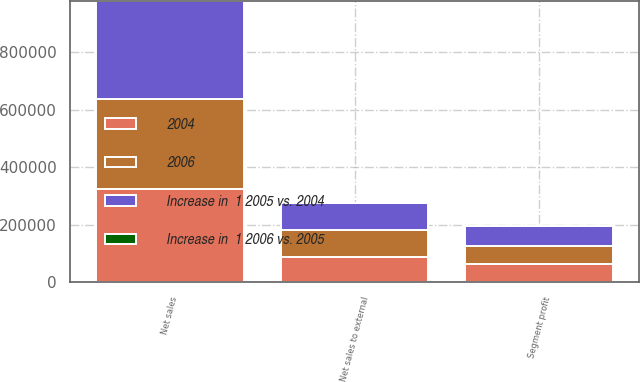<chart> <loc_0><loc_0><loc_500><loc_500><stacked_bar_chart><ecel><fcel>Net sales<fcel>Net sales to external<fcel>Segment profit<nl><fcel>Increase in  1 2005 vs. 2004<fcel>340849<fcel>96311<fcel>70083<nl><fcel>2004<fcel>324901<fcel>88138<fcel>65471<nl><fcel>2006<fcel>312992<fcel>92321<fcel>59576<nl><fcel>Increase in  1 2006 vs. 2005<fcel>5<fcel>9<fcel>7<nl></chart> 